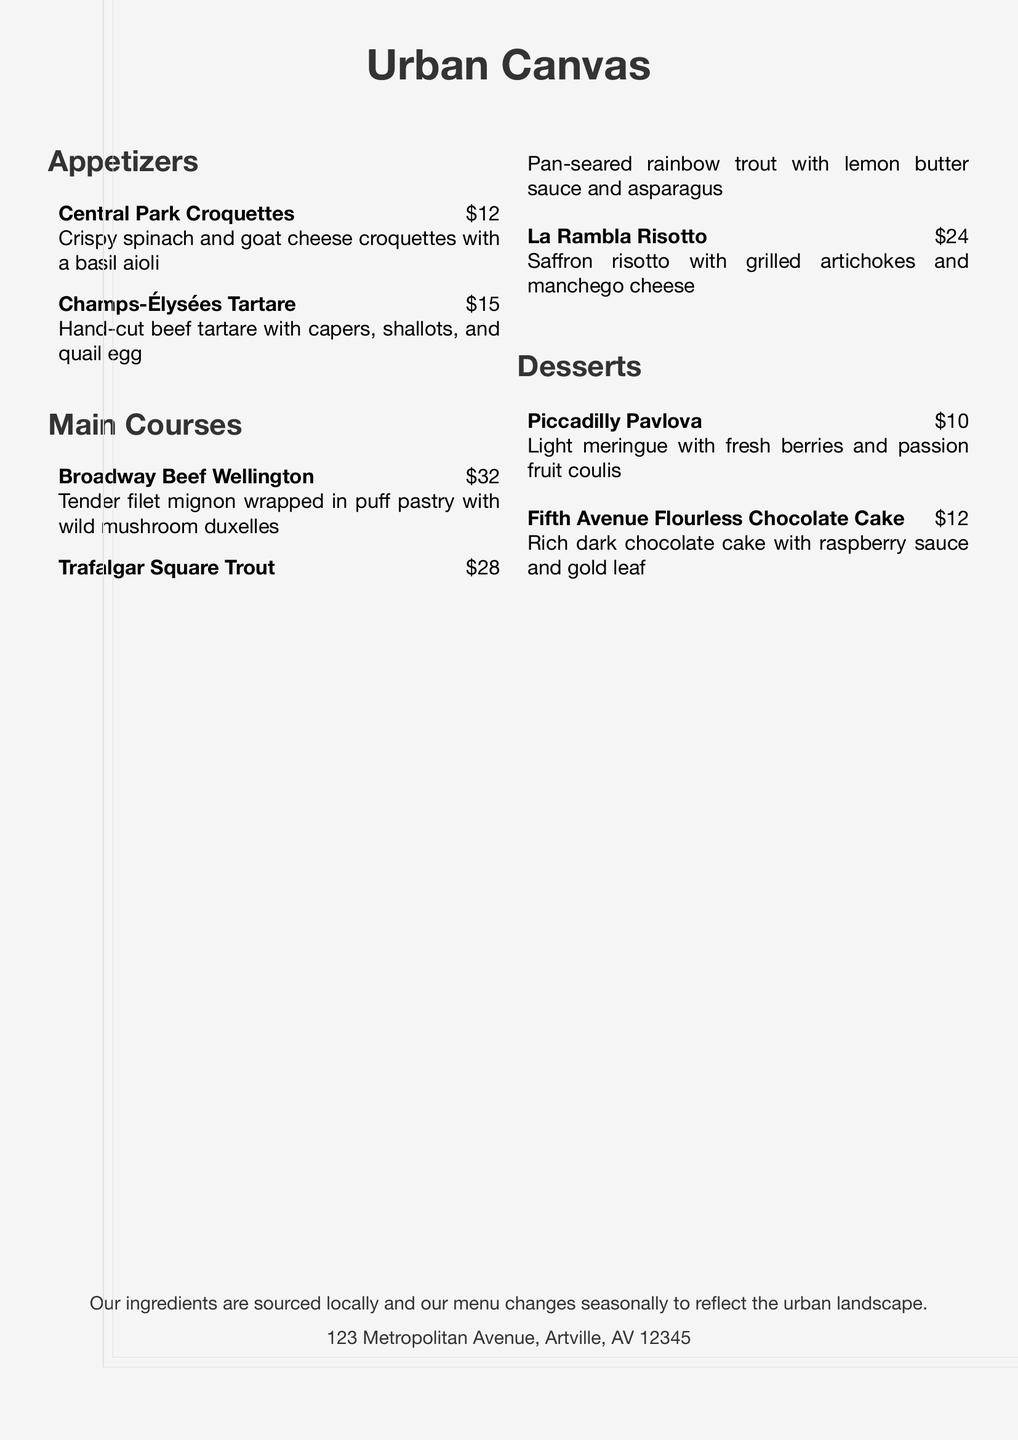What is the name of the first appetizer? The first appetizer listed is "Central Park Croquettes."
Answer: Central Park Croquettes How much does the Champs-Élysées Tartare cost? The cost of the Champs-Élysées Tartare is listed as $15.
Answer: $15 What is the main ingredient in the Broadway Beef Wellington? The main ingredient in the Broadway Beef Wellington is filet mignon.
Answer: Filet mignon Which dessert features fresh berries? The dessert that features fresh berries is "Piccadilly Pavlova."
Answer: Piccadilly Pavlova What type of sauce accompanies the Trafalgar Square Trout? The sauce that accompanies the Trafalgar Square Trout is lemon butter sauce.
Answer: Lemon butter sauce How many main courses are listed on the menu? There are a total of three main courses listed on the menu.
Answer: Three What type of cake is the Fifth Avenue dessert? The Fifth Avenue dessert is a flourless chocolate cake.
Answer: Flourless chocolate cake What theme does the menu design reflect? The menu design reflects an urban landscape theme.
Answer: Urban landscape 